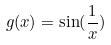Convert formula to latex. <formula><loc_0><loc_0><loc_500><loc_500>g ( x ) = \sin ( \frac { 1 } { x } )</formula> 